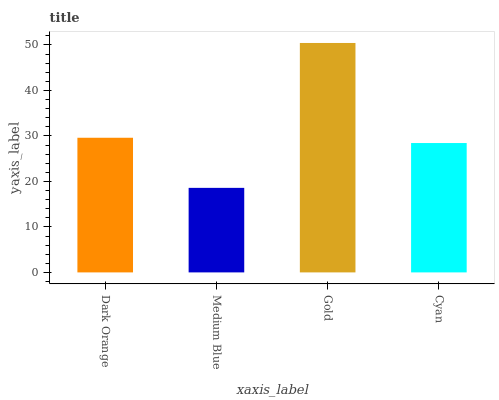Is Medium Blue the minimum?
Answer yes or no. Yes. Is Gold the maximum?
Answer yes or no. Yes. Is Gold the minimum?
Answer yes or no. No. Is Medium Blue the maximum?
Answer yes or no. No. Is Gold greater than Medium Blue?
Answer yes or no. Yes. Is Medium Blue less than Gold?
Answer yes or no. Yes. Is Medium Blue greater than Gold?
Answer yes or no. No. Is Gold less than Medium Blue?
Answer yes or no. No. Is Dark Orange the high median?
Answer yes or no. Yes. Is Cyan the low median?
Answer yes or no. Yes. Is Medium Blue the high median?
Answer yes or no. No. Is Dark Orange the low median?
Answer yes or no. No. 